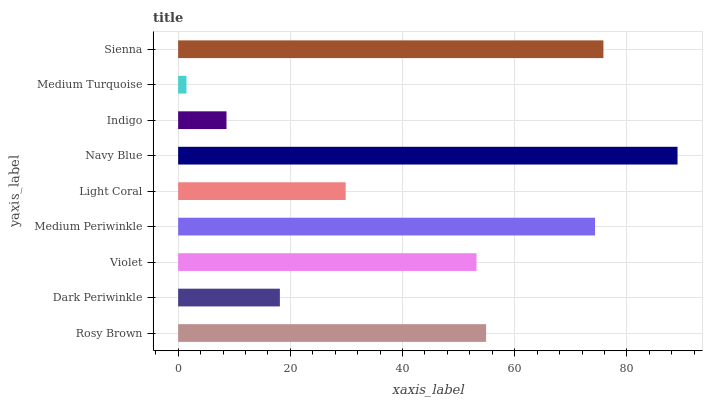Is Medium Turquoise the minimum?
Answer yes or no. Yes. Is Navy Blue the maximum?
Answer yes or no. Yes. Is Dark Periwinkle the minimum?
Answer yes or no. No. Is Dark Periwinkle the maximum?
Answer yes or no. No. Is Rosy Brown greater than Dark Periwinkle?
Answer yes or no. Yes. Is Dark Periwinkle less than Rosy Brown?
Answer yes or no. Yes. Is Dark Periwinkle greater than Rosy Brown?
Answer yes or no. No. Is Rosy Brown less than Dark Periwinkle?
Answer yes or no. No. Is Violet the high median?
Answer yes or no. Yes. Is Violet the low median?
Answer yes or no. Yes. Is Medium Periwinkle the high median?
Answer yes or no. No. Is Indigo the low median?
Answer yes or no. No. 